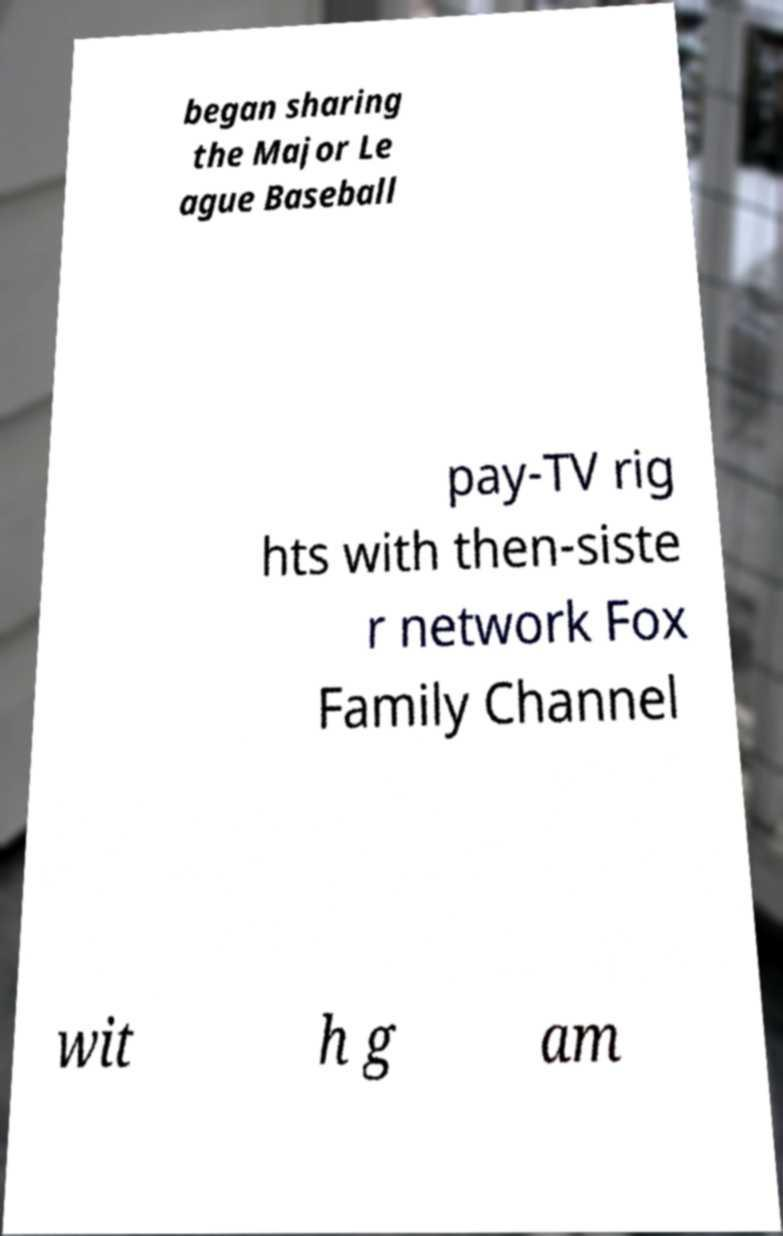There's text embedded in this image that I need extracted. Can you transcribe it verbatim? began sharing the Major Le ague Baseball pay-TV rig hts with then-siste r network Fox Family Channel wit h g am 